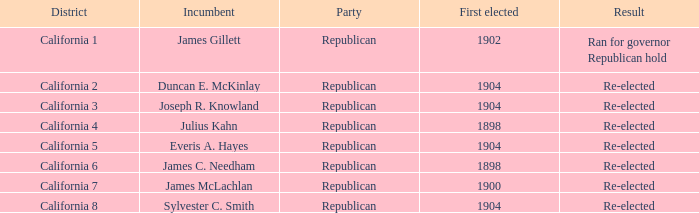What's the peak first elected with a result of re-elected and district of california 5? 1904.0. 